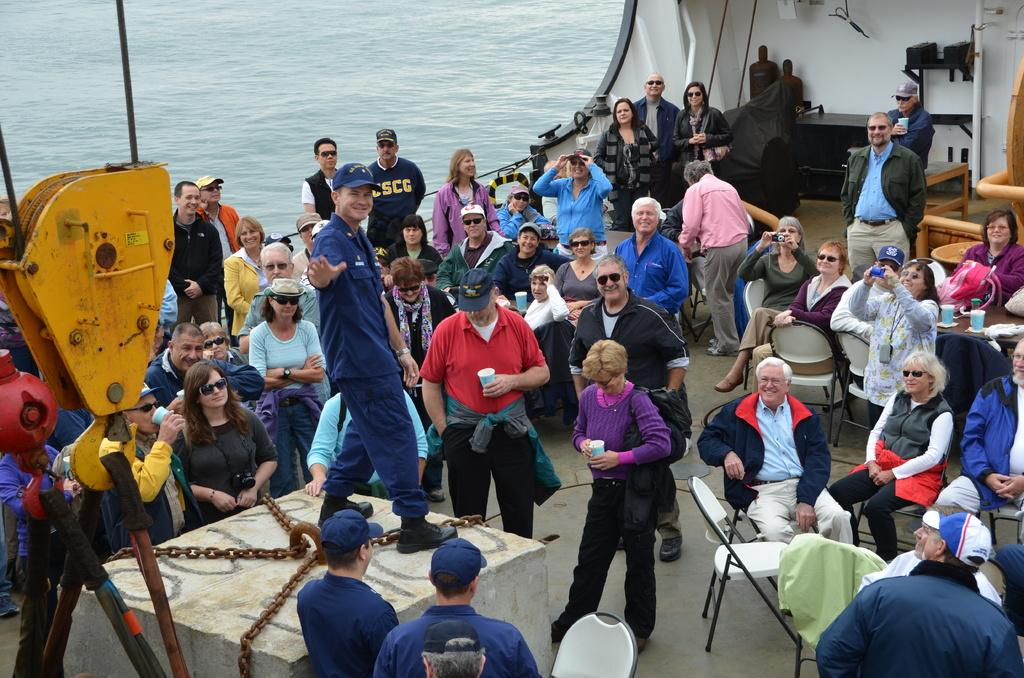What is the setting of the image? The people are on a ship, which is on water. What are the people doing in the image? The people are in a group, but their specific activity is not mentioned. What is the block tied with chains in the image? The block tied with chains is an object in the image, but its purpose or significance is not specified. What else can be seen around the block and the people? There are other unspecified things around the block and the people, but their nature is not described. What type of vegetable is being used as a walkway for the turkey in the image? There is no vegetable or turkey present in the image; it features a group of people on a ship with a block tied with chains and other unspecified things. 